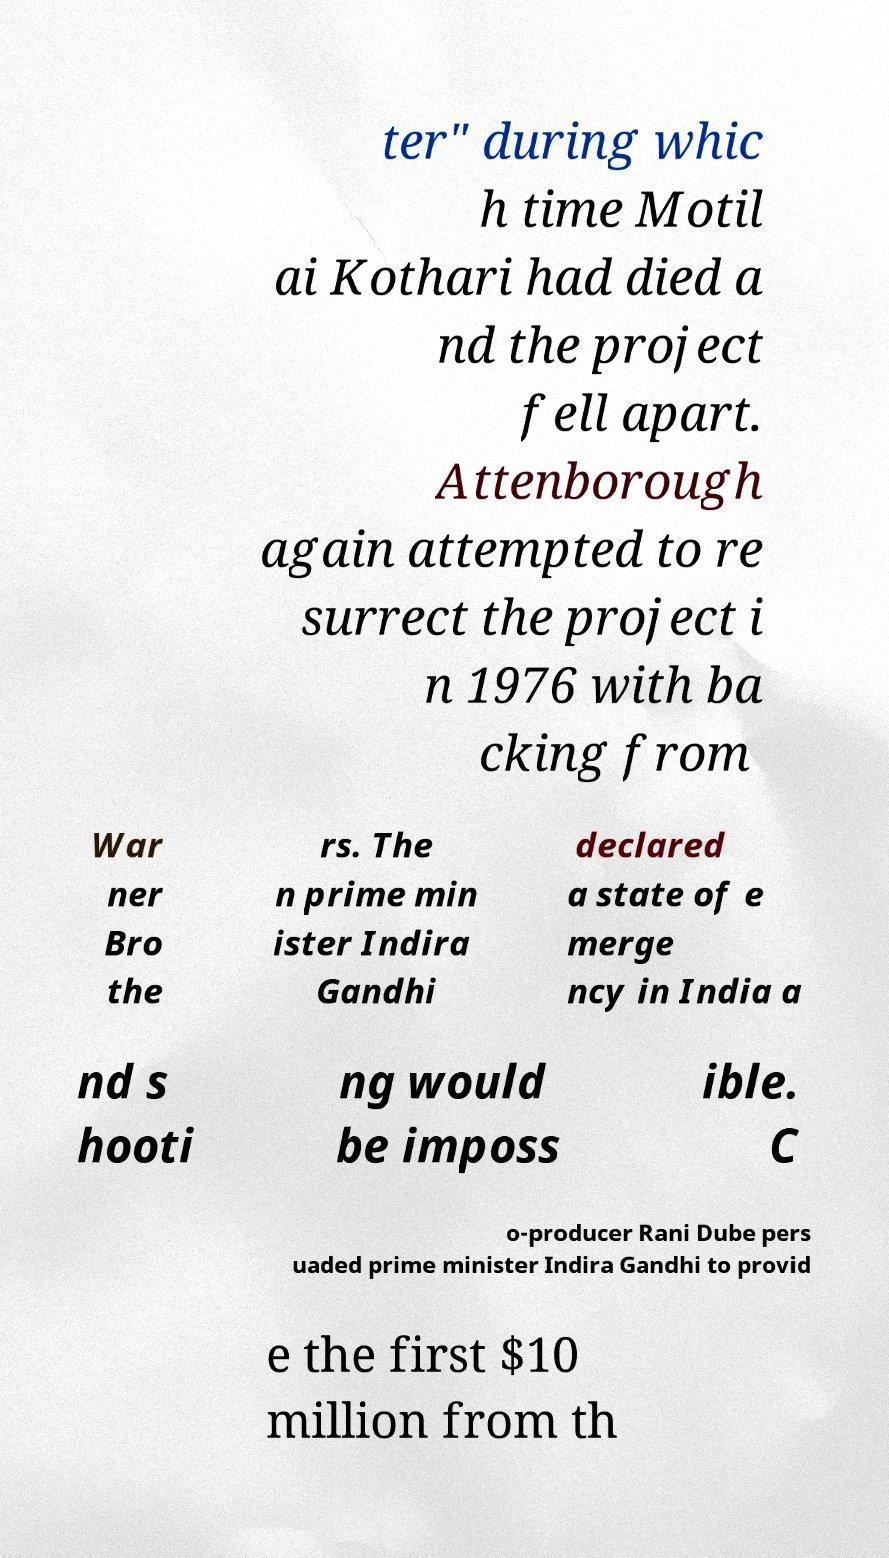Could you extract and type out the text from this image? ter" during whic h time Motil ai Kothari had died a nd the project fell apart. Attenborough again attempted to re surrect the project i n 1976 with ba cking from War ner Bro the rs. The n prime min ister Indira Gandhi declared a state of e merge ncy in India a nd s hooti ng would be imposs ible. C o-producer Rani Dube pers uaded prime minister Indira Gandhi to provid e the first $10 million from th 